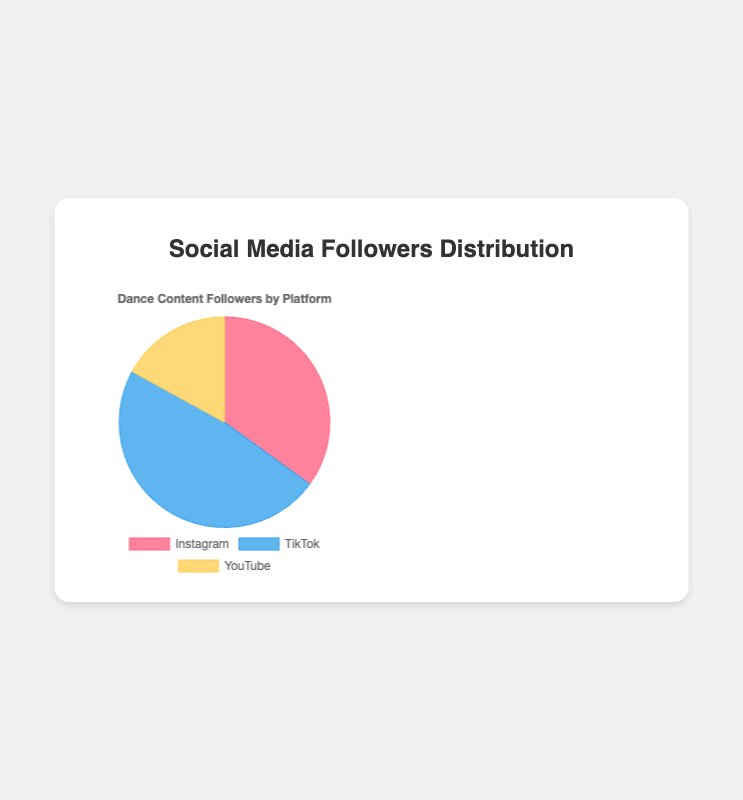Which platform has the highest number of followers? By looking at the largest segment in the pie chart, we can determine that TikTok has the highest number of followers.
Answer: TikTok Which two platforms combined have more followers than the third platform? Summing the followers of Instagram and YouTube, (35000+17000=52000), which is more than TikTok’s 48000 followers. Conversely, summing TikTok and YouTube totals more than Instagram's followers. This shows Instagram and YouTube combined, as do TikTok and YouTube, have more followers than the third platform
Answer: Instagram and YouTube What percentage of total followers does Instagram have compared to the total followers across all platforms? The total number of followers across all platforms is (35000+48000+17000=100000). Instagram followers are 35000. Therefore, the percentage is (35000/100000*100=35%).
Answer: 35% How does the number of YouTube followers compare to Instagram followers visually on the chart? The YouTube segment in the pie chart is visually smaller than the Instagram segment, indicating that YouTube has fewer followers.
Answer: Fewer If you wanted to balance the number of followers between platforms, how many more followers would YouTube need to reach the same number of Instagram followers? Instagram has 35000 followers, and YouTube has 17000 followers. To balance, YouTube needs (35000-17000=18000) more followers.
Answer: 18000 What’s the difference in the number of followers between the platform with the most followers and the platform with the fewest followers? TikTok has 48000 followers, and YouTube has 17000 followers. The difference is (48000-17000=31000).
Answer: 31000 What is the combined percentage of YouTube and TikTok followers out of the total followers? The combined number of followers for YouTube and TikTok is (17000+48000=65000). The total followers are 100000. The percentage is (65000/100000*100=65%).
Answer: 65% By what percentage does TikTok exceed YouTube in followers? TikTok exceeds YouTube by (48000-17000=31000) followers. The percentage is calculated as (31000/17000*100≈182.35%).
Answer: 182.35% How many followers in total do you have across all platforms? By summing the number of followers on Instagram, TikTok, and YouTube, (35000+48000+17000 = 100000).
Answer: 100000 If the followers were to be evenly distributed among the three platforms, how many more followers would YouTube need? Each platform would need (100000/3≈33333.33) followers for even distribution. YouTube currently has 17000 followers, so it would need (33333.33-17000≈16333.33) more followers.
Answer: 16333.33 